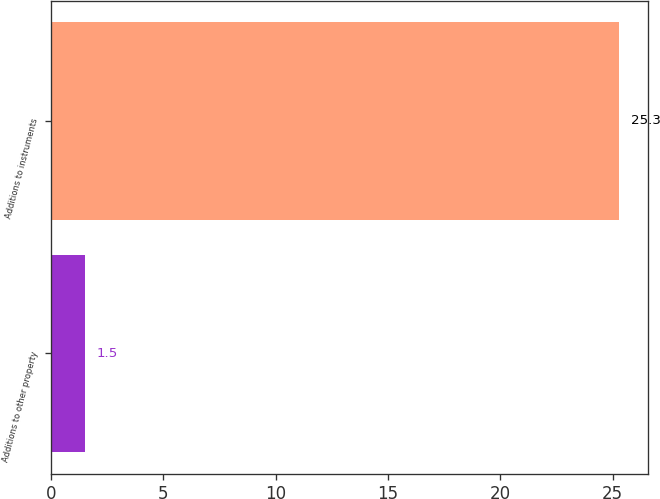Convert chart to OTSL. <chart><loc_0><loc_0><loc_500><loc_500><bar_chart><fcel>Additions to other property<fcel>Additions to instruments<nl><fcel>1.5<fcel>25.3<nl></chart> 